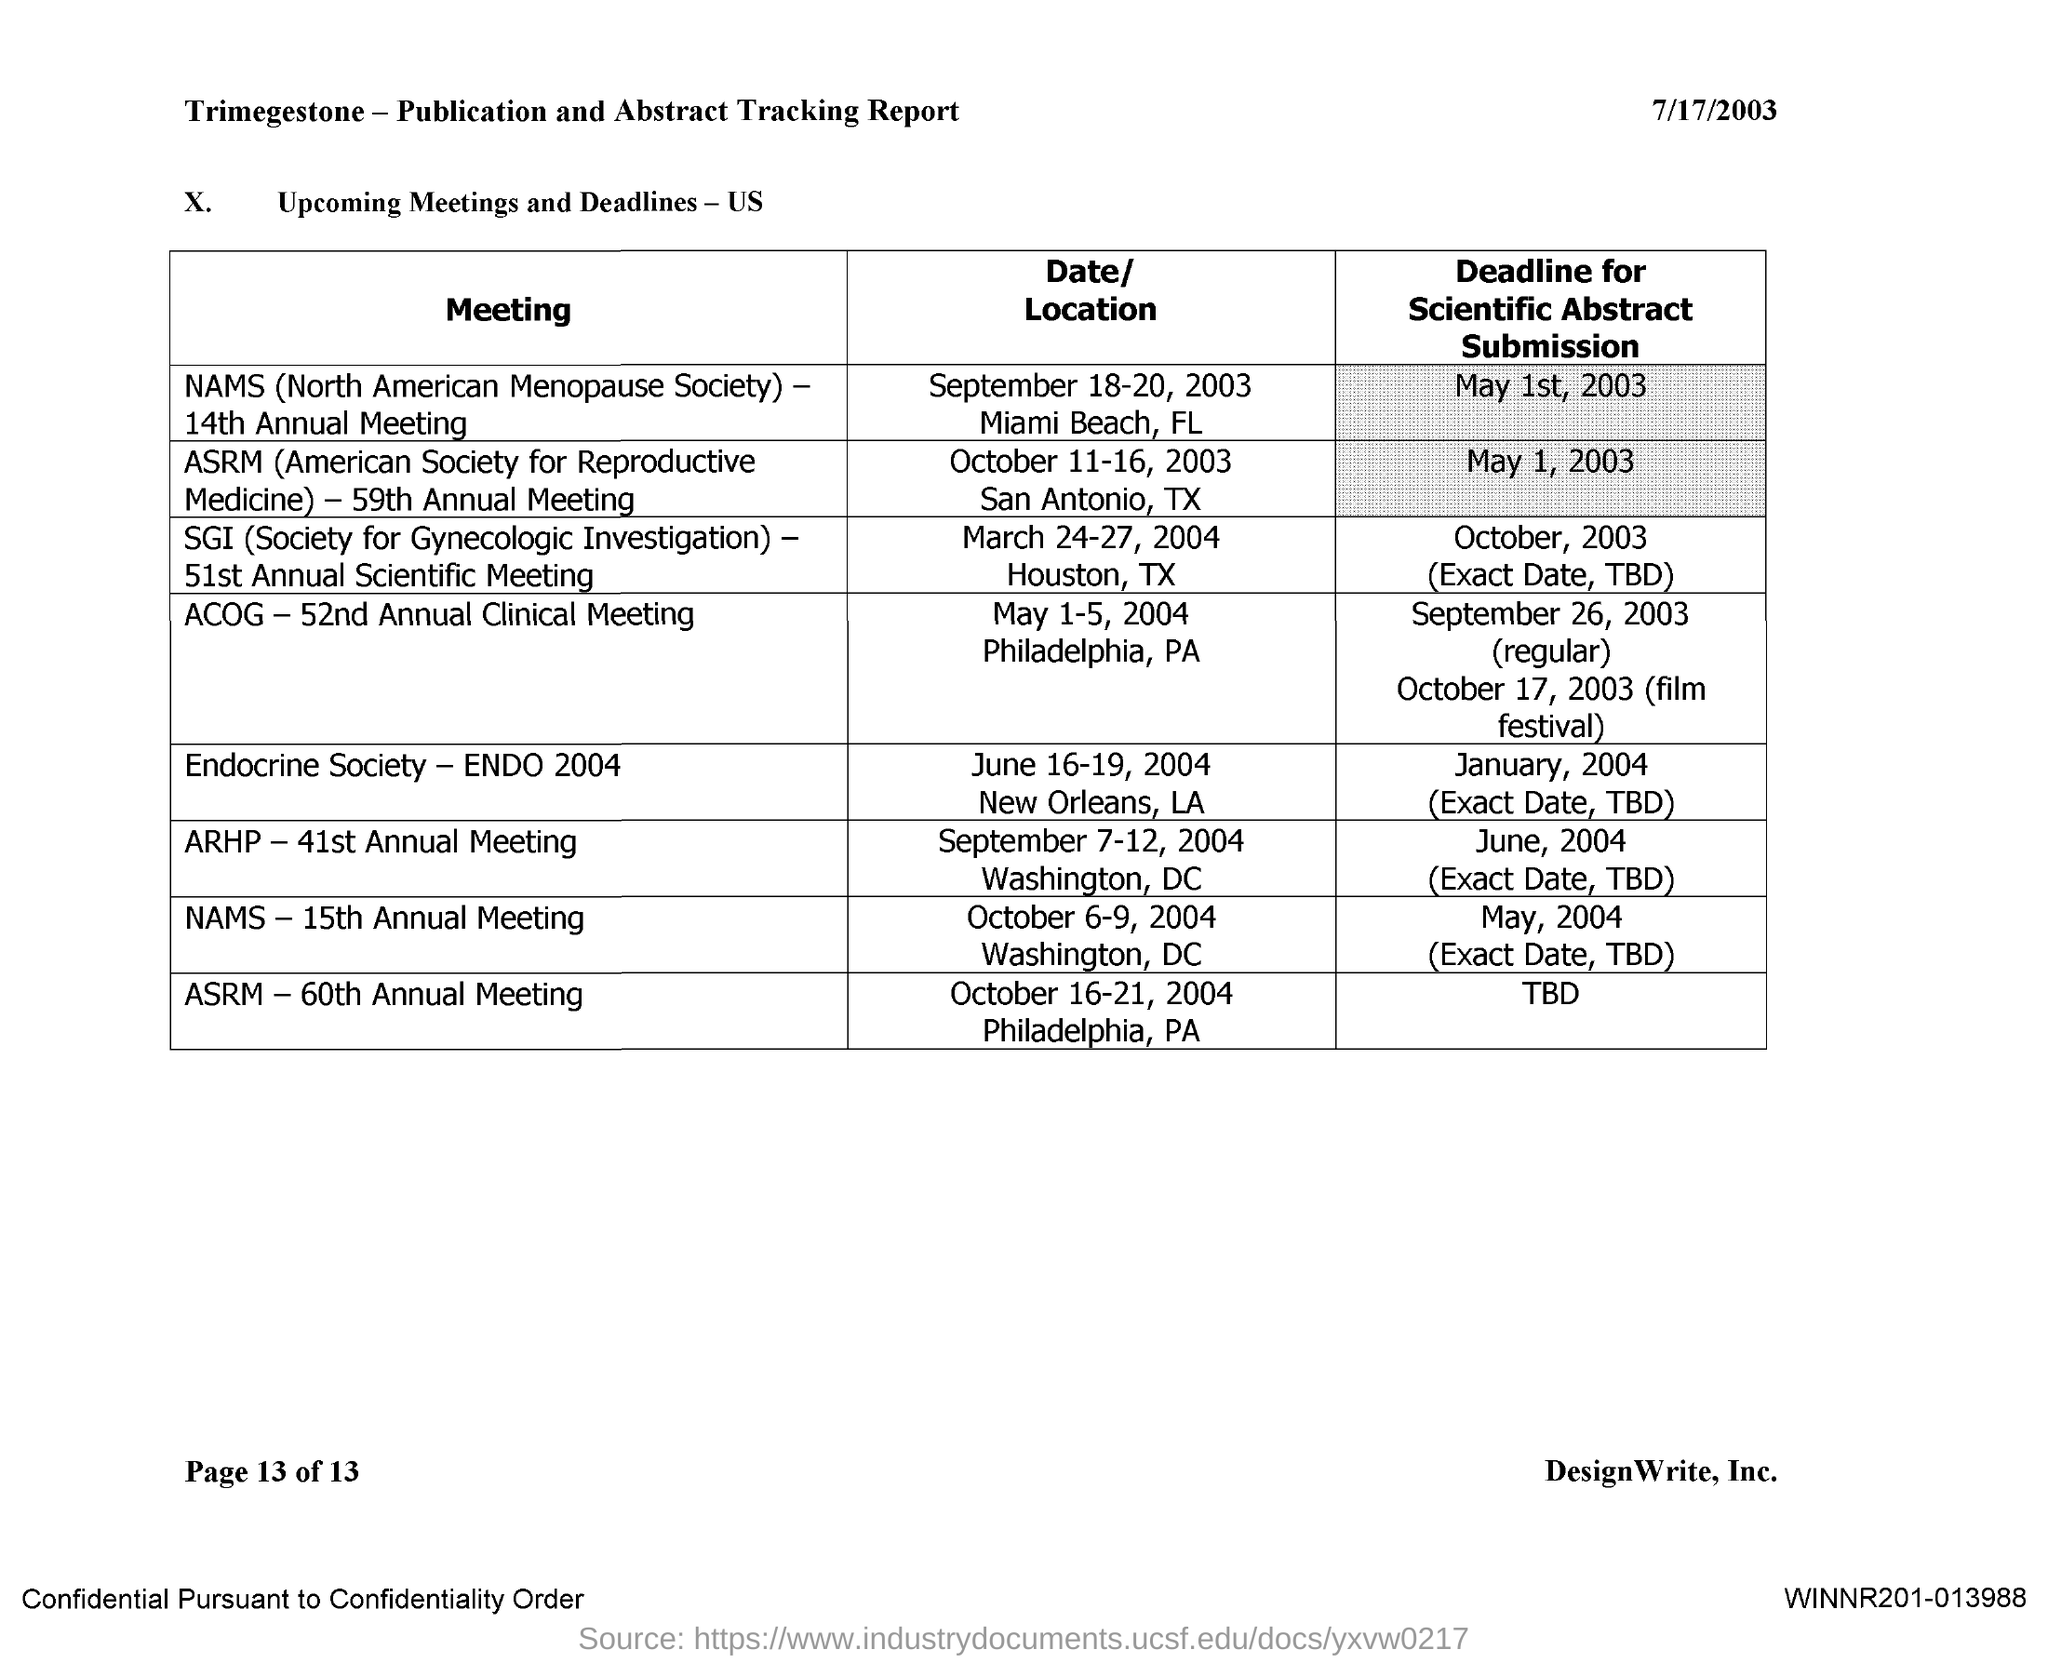Mention a couple of crucial points in this snapshot. The ACOG 52nd Annual Clinical Meeting will take place from May 1st to May 5th, 2004. 